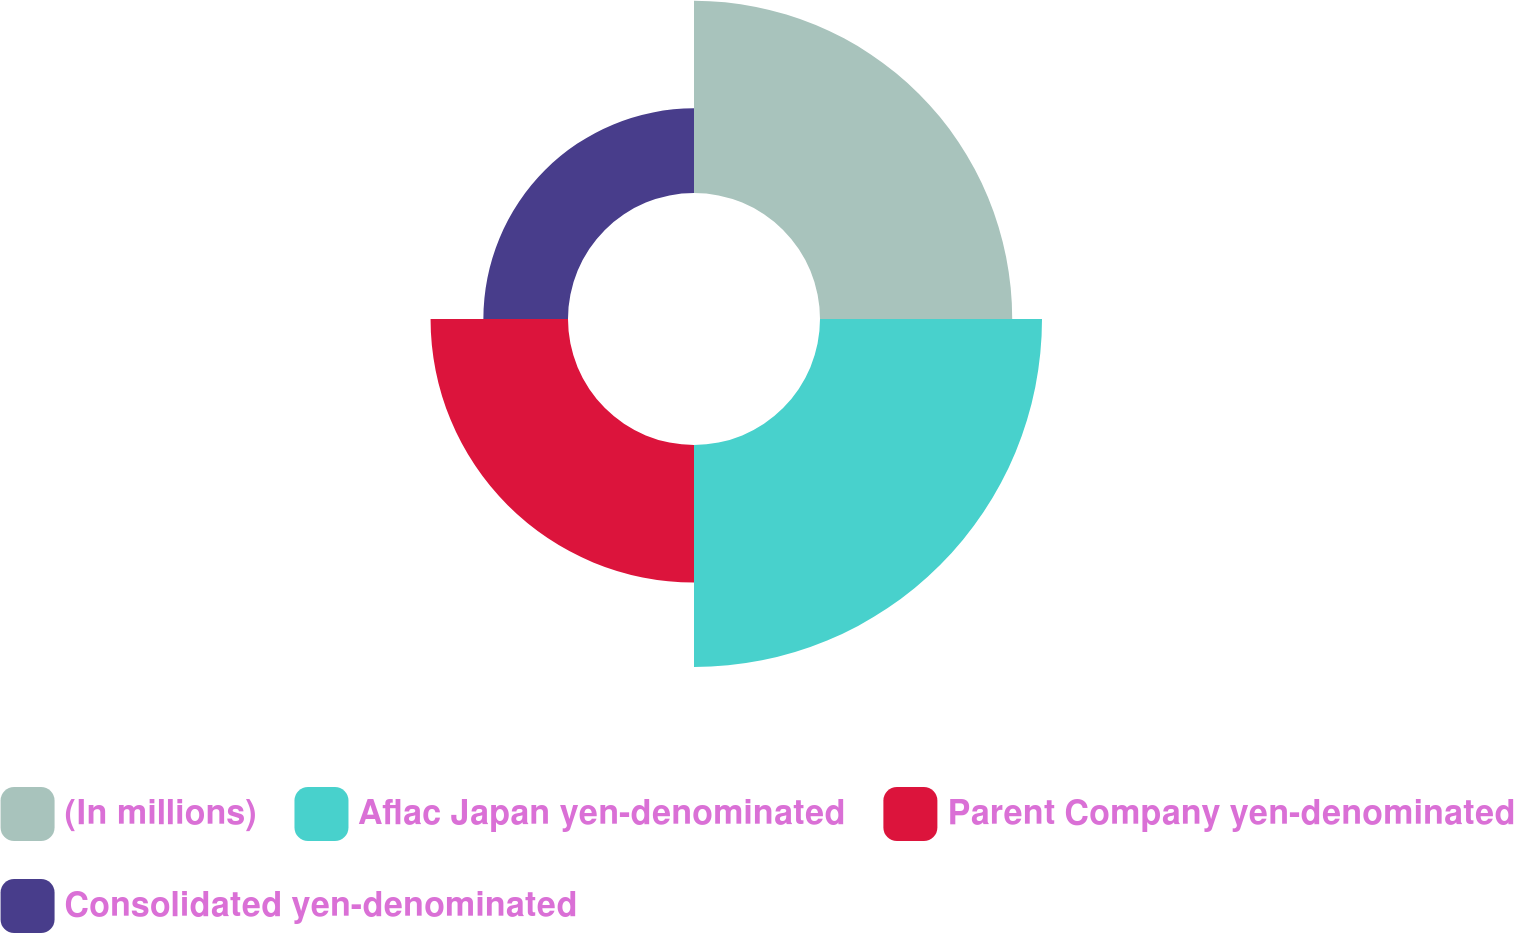<chart> <loc_0><loc_0><loc_500><loc_500><pie_chart><fcel>(In millions)<fcel>Aflac Japan yen-denominated<fcel>Parent Company yen-denominated<fcel>Consolidated yen-denominated<nl><fcel>30.21%<fcel>34.89%<fcel>21.6%<fcel>13.3%<nl></chart> 